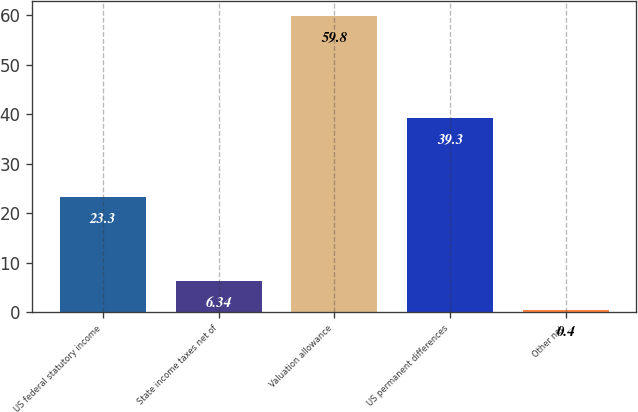<chart> <loc_0><loc_0><loc_500><loc_500><bar_chart><fcel>US federal statutory income<fcel>State income taxes net of<fcel>Valuation allowance<fcel>US permanent differences<fcel>Other net<nl><fcel>23.3<fcel>6.34<fcel>59.8<fcel>39.3<fcel>0.4<nl></chart> 